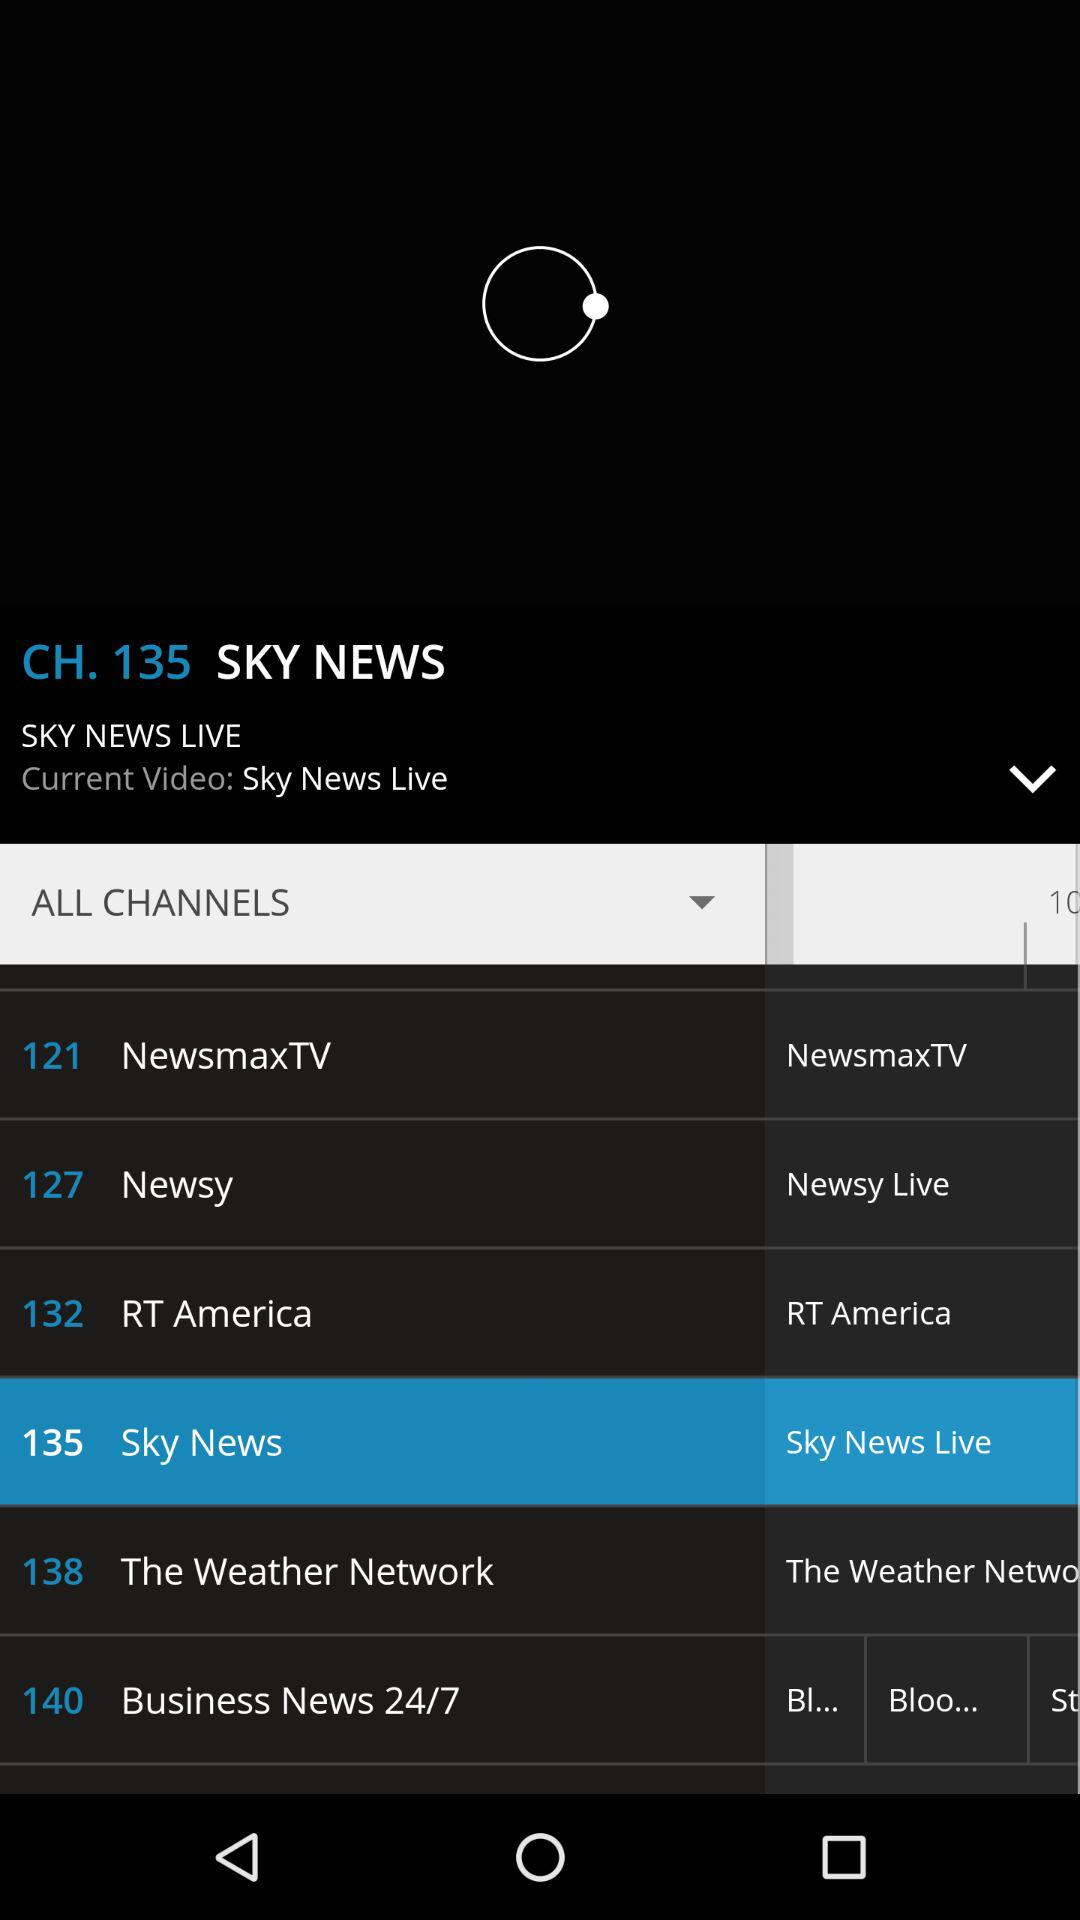How many channels are there on the screen?
Answer the question using a single word or phrase. 6 